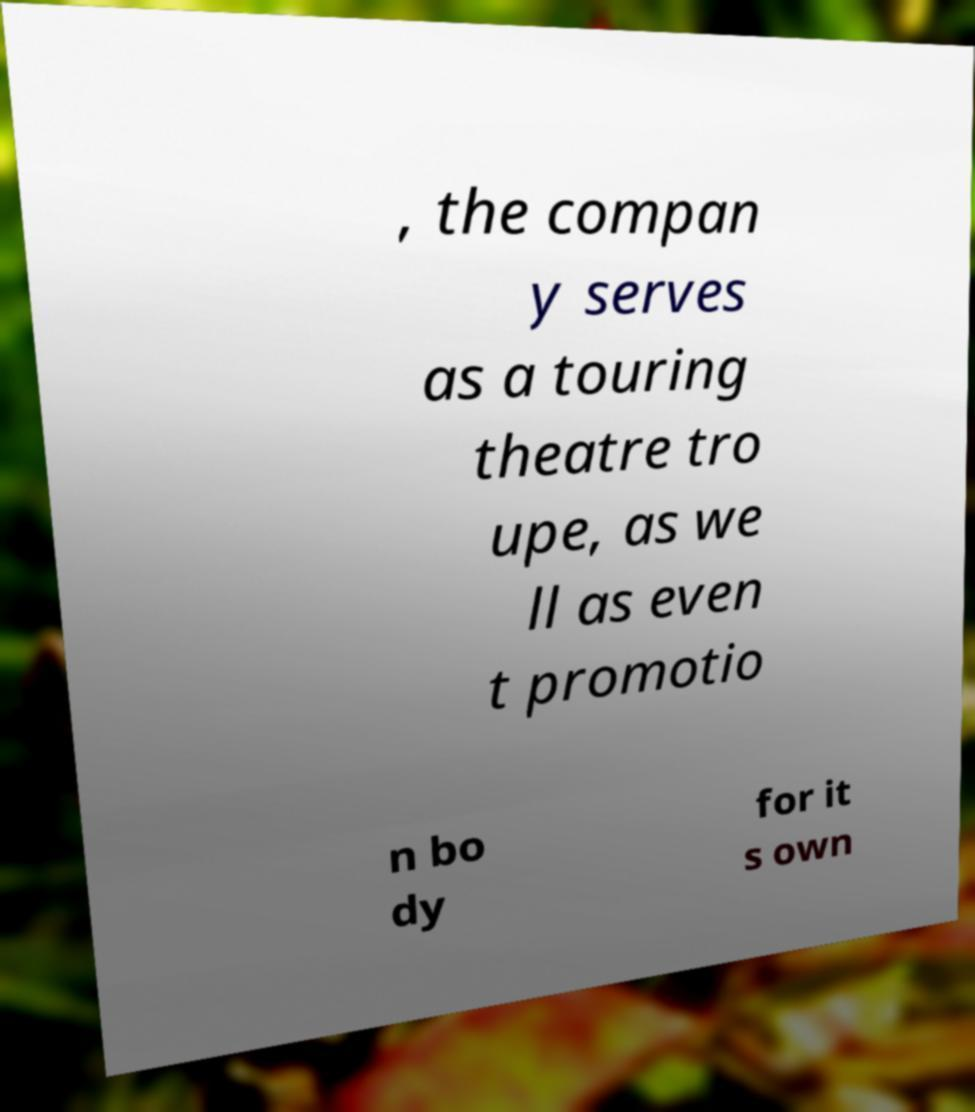Can you read and provide the text displayed in the image?This photo seems to have some interesting text. Can you extract and type it out for me? , the compan y serves as a touring theatre tro upe, as we ll as even t promotio n bo dy for it s own 